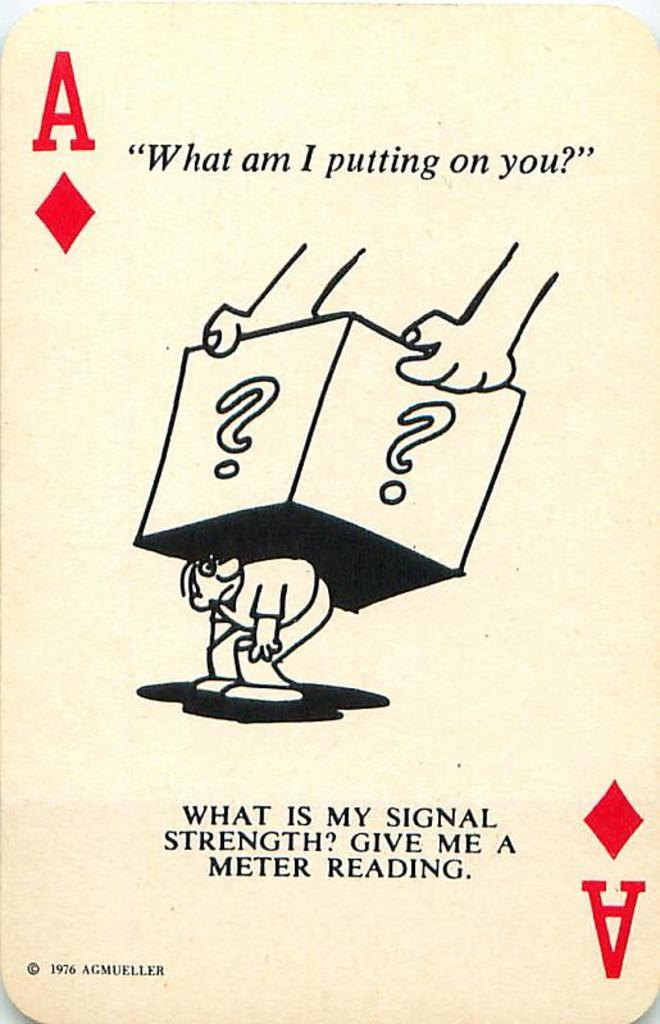<image>
Offer a succinct explanation of the picture presented. A playing card of an ace with a man drawn on it with a box over it and the words, what am i putting on you, written above. 